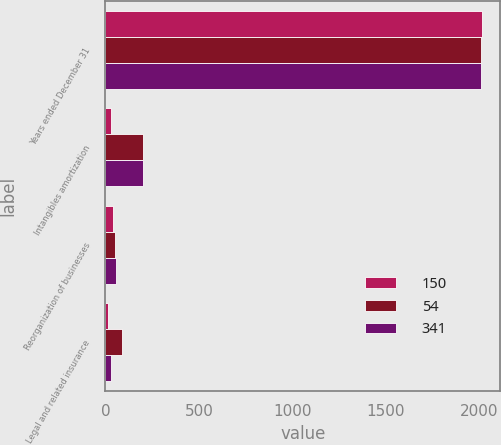Convert chart to OTSL. <chart><loc_0><loc_0><loc_500><loc_500><stacked_bar_chart><ecel><fcel>Years ended December 31<fcel>Intangibles amortization<fcel>Reorganization of businesses<fcel>Legal and related insurance<nl><fcel>150<fcel>2012<fcel>29<fcel>41<fcel>16<nl><fcel>54<fcel>2011<fcel>200<fcel>52<fcel>88<nl><fcel>341<fcel>2010<fcel>203<fcel>54<fcel>29<nl></chart> 